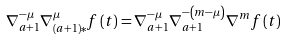Convert formula to latex. <formula><loc_0><loc_0><loc_500><loc_500>\nabla _ { a + 1 } ^ { - \mu } \nabla _ { \left ( a + 1 \right ) \ast } ^ { \mu } f \left ( t \right ) = \nabla _ { a + 1 } ^ { - \mu } \nabla _ { a + 1 } ^ { - \left ( m - \mu \right ) } \nabla ^ { m } f \left ( t \right )</formula> 